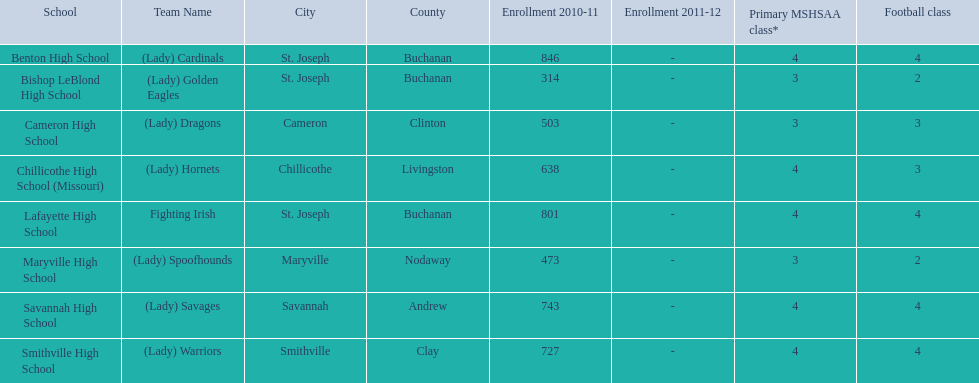Write the full table. {'header': ['School', 'Team Name', 'City', 'County', 'Enrollment 2010-11', 'Enrollment 2011-12', 'Primary MSHSAA class*', 'Football class'], 'rows': [['Benton High School', '(Lady) Cardinals', 'St. Joseph', 'Buchanan', '846', '-', '4', '4'], ['Bishop LeBlond High School', '(Lady) Golden Eagles', 'St. Joseph', 'Buchanan', '314', '-', '3', '2'], ['Cameron High School', '(Lady) Dragons', 'Cameron', 'Clinton', '503', '-', '3', '3'], ['Chillicothe High School (Missouri)', '(Lady) Hornets', 'Chillicothe', 'Livingston', '638', '-', '4', '3'], ['Lafayette High School', 'Fighting Irish', 'St. Joseph', 'Buchanan', '801', '-', '4', '4'], ['Maryville High School', '(Lady) Spoofhounds', 'Maryville', 'Nodaway', '473', '-', '3', '2'], ['Savannah High School', '(Lady) Savages', 'Savannah', 'Andrew', '743', '-', '4', '4'], ['Smithville High School', '(Lady) Warriors', 'Smithville', 'Clay', '727', '-', '4', '4']]} What are all of the schools? Benton High School, Bishop LeBlond High School, Cameron High School, Chillicothe High School (Missouri), Lafayette High School, Maryville High School, Savannah High School, Smithville High School. How many football classes do they have? 4, 2, 3, 3, 4, 2, 4, 4. What about their enrollment? 846, 314, 503, 638, 801, 473, 743, 727. Which schools have 3 football classes? Cameron High School, Chillicothe High School (Missouri). And of those schools, which has 638 students? Chillicothe High School (Missouri). 